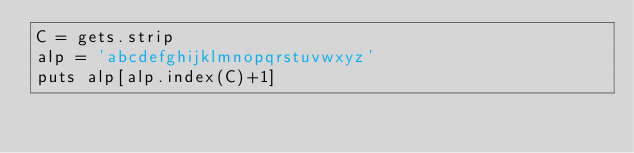Convert code to text. <code><loc_0><loc_0><loc_500><loc_500><_Ruby_>C = gets.strip
alp = 'abcdefghijklmnopqrstuvwxyz'
puts alp[alp.index(C)+1]</code> 